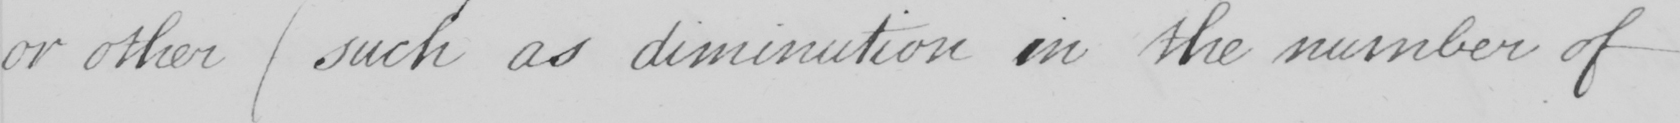Please provide the text content of this handwritten line. or other  ( such as diminution in the number of 